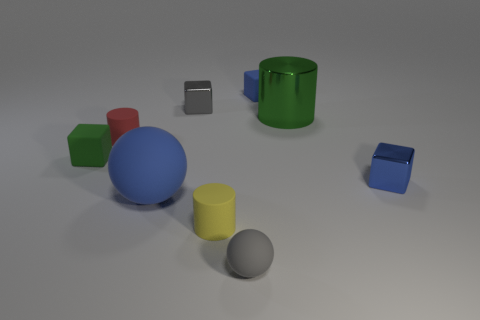There is a green object that is the same shape as the tiny blue metal thing; what is it made of?
Provide a short and direct response. Rubber. There is a sphere on the left side of the tiny gray thing that is in front of the tiny metallic cube to the right of the gray block; how big is it?
Provide a succinct answer. Large. Is the number of tiny blue metallic things the same as the number of blue matte objects?
Provide a short and direct response. No. Are there any cylinders to the left of the red thing?
Your answer should be very brief. No. The blue sphere that is made of the same material as the green cube is what size?
Your answer should be very brief. Large. How many green metal objects are the same shape as the big matte thing?
Keep it short and to the point. 0. Does the tiny gray sphere have the same material as the big object that is left of the gray rubber thing?
Make the answer very short. Yes. Is the number of blue metallic objects that are on the left side of the gray rubber ball greater than the number of green rubber objects?
Your answer should be compact. No. The object that is the same color as the small matte sphere is what shape?
Provide a succinct answer. Cube. Are there any other small blocks that have the same material as the tiny gray cube?
Give a very brief answer. Yes. 